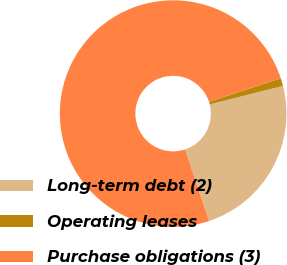<chart> <loc_0><loc_0><loc_500><loc_500><pie_chart><fcel>Long-term debt (2)<fcel>Operating leases<fcel>Purchase obligations (3)<nl><fcel>23.8%<fcel>1.11%<fcel>75.09%<nl></chart> 